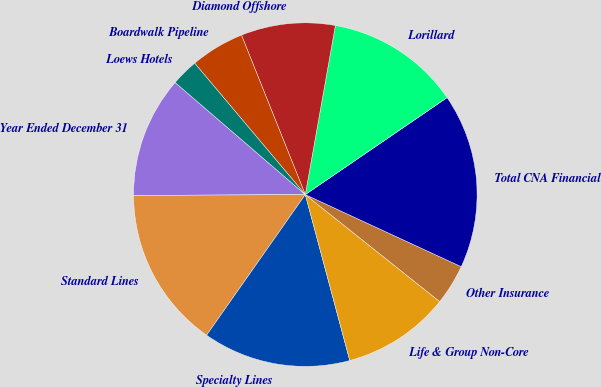Convert chart. <chart><loc_0><loc_0><loc_500><loc_500><pie_chart><fcel>Year Ended December 31<fcel>Standard Lines<fcel>Specialty Lines<fcel>Life & Group Non-Core<fcel>Other Insurance<fcel>Total CNA Financial<fcel>Lorillard<fcel>Diamond Offshore<fcel>Boardwalk Pipeline<fcel>Loews Hotels<nl><fcel>11.39%<fcel>15.18%<fcel>13.91%<fcel>10.13%<fcel>3.81%<fcel>16.44%<fcel>12.65%<fcel>8.86%<fcel>5.08%<fcel>2.55%<nl></chart> 